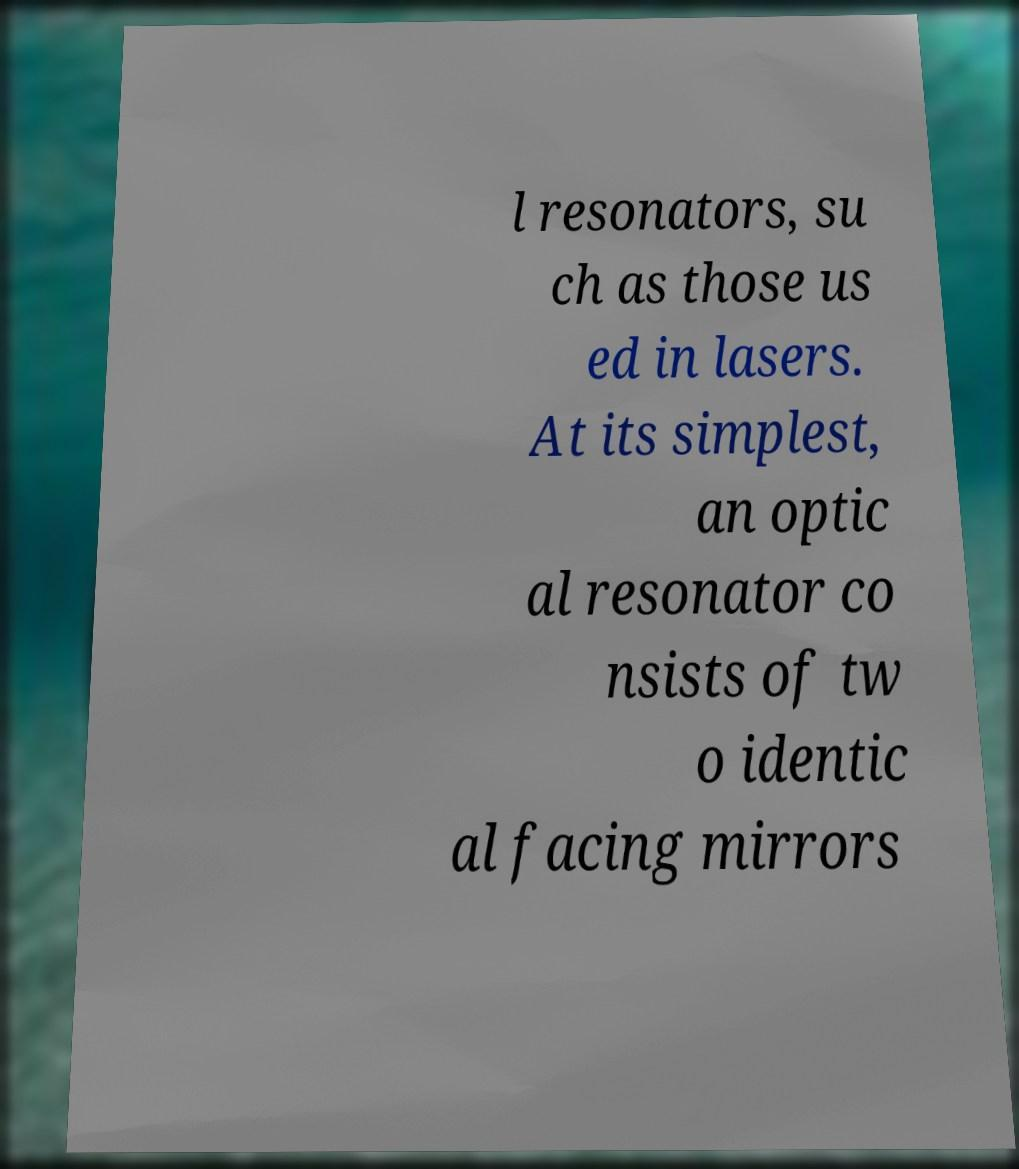Can you read and provide the text displayed in the image?This photo seems to have some interesting text. Can you extract and type it out for me? l resonators, su ch as those us ed in lasers. At its simplest, an optic al resonator co nsists of tw o identic al facing mirrors 